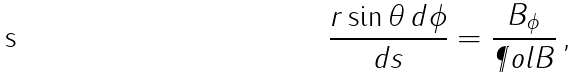Convert formula to latex. <formula><loc_0><loc_0><loc_500><loc_500>\frac { r \sin \theta \, d \phi } { d s } = \frac { B _ { \phi } } { \P o l { B } } \, ,</formula> 